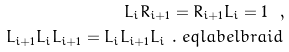<formula> <loc_0><loc_0><loc_500><loc_500>L _ { i } R _ { i + 1 } = R _ { i + 1 } L _ { i } = 1 \ , \\ L _ { i + 1 } L _ { i } L _ { i + 1 } = L _ { i } L _ { i + 1 } L _ { i } \ . \ e q l a b e l { b r a i d }</formula> 